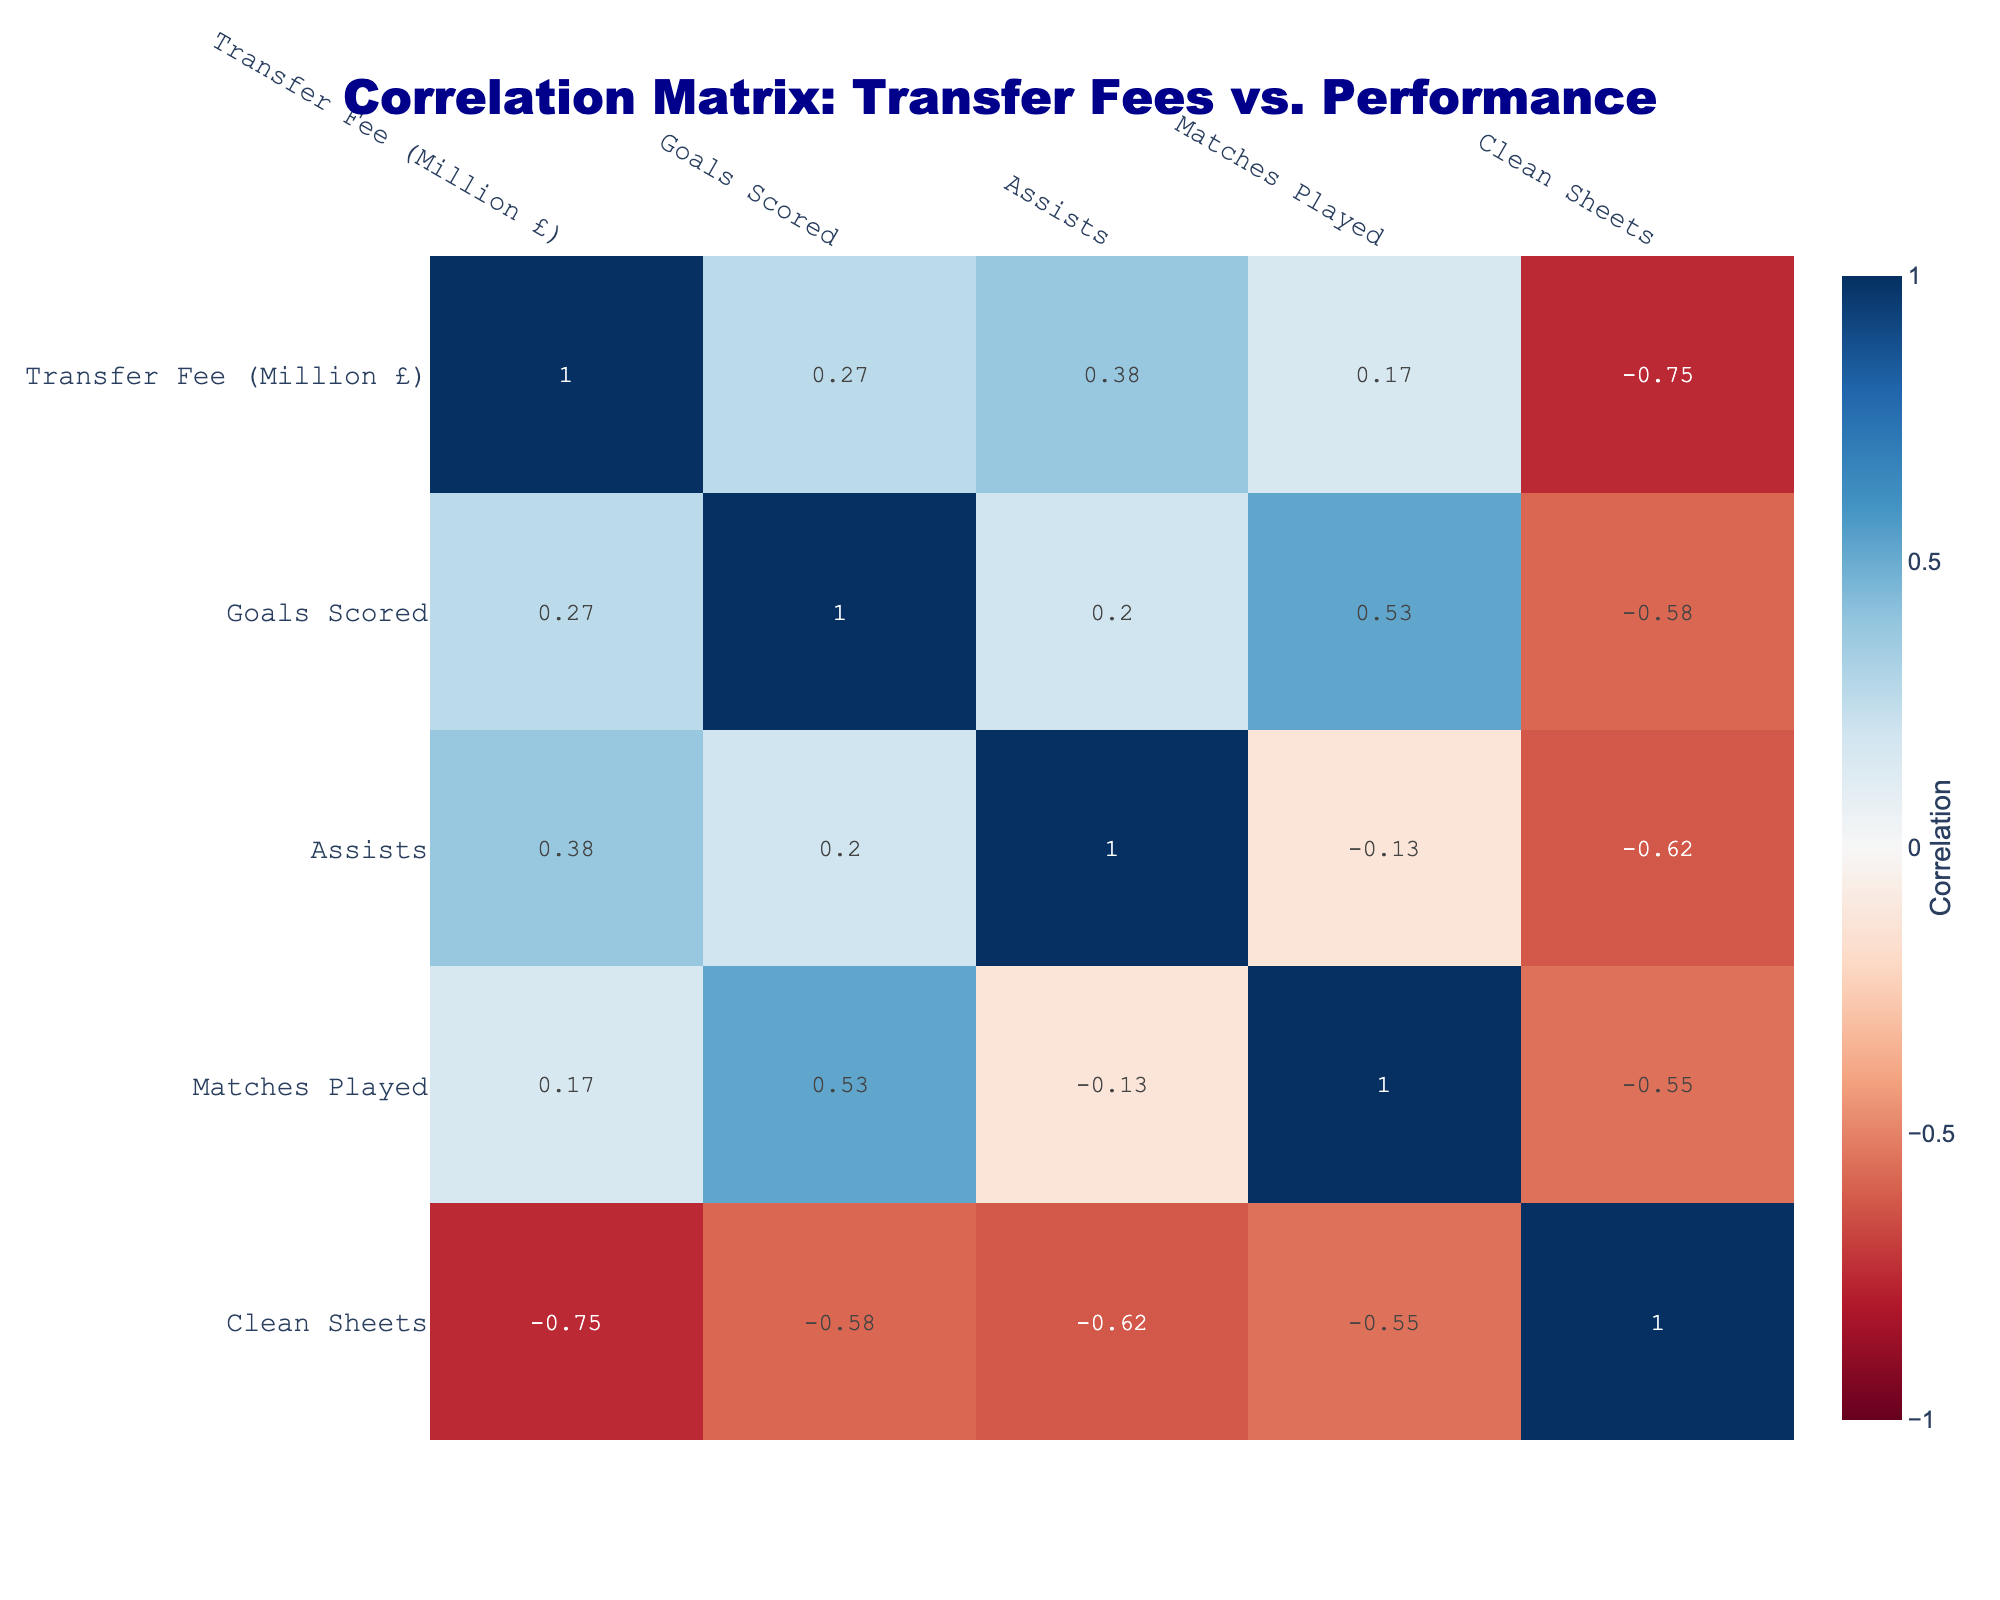What is the transfer fee of Jonson Clarke-Harris? By looking at the table, Jonson Clarke-Harris's row shows a transfer fee of 1.5 million pounds.
Answer: 1.5 million £ Which player has the highest number of goals scored? The table indicates that Jonson Clarke-Harris has scored 20 goals, which is higher than any other player listed.
Answer: Jonson Clarke-Harris What is the average number of assists across all players? To find the average, sum all assists (2 + 5 + 3 + 1 + 1 + 4 + 6 + 5 = 27) and then divide by the number of players (8). The average is 27/8 = 3.375.
Answer: 3.375 Is it true that Keenan Carole has more clean sheets than Jack Taylor? Keenan Carole has 1 clean sheet while Jack Taylor has 2 clean sheets, so the statement is false.
Answer: No What is the total number of matches played by all players? Adding the matches played by each player (30 + 28 + 31 + 29 + 25 + 30 + 27 + 26 = 256) gives the total number of matches played.
Answer: 256 Which player has the second highest transfer fee? By examining the transfer fees, Siriki Dembélé has a fee of 2.0 million pounds, and the next highest after that is Keenan Carole at 1.8 million pounds.
Answer: Keenan Carole Does Joe Ward have more goals than Harrison Burrows? Joe Ward has 7 goals, while Harrison Burrows has 6 goals. Therefore, the statement is true.
Answer: Yes What is the correlation between transfer fee and goals scored? The correlation coefficient is a numerical value representing how closely related the two variables are, and we would look at the intersection of the relevant row and column in the correlation table. The exact value would need to be derived from the correlation table output.
Answer: [dependent on table value] Has any player scored more than 6 goals and had 3 or more clean sheets? Analyzing the data, Jonson Clarke-Harris (20 goals, 1 clean sheet) and Siriki Dembélé (8 goals, 1 clean sheet) are ruled out as they don't meet the clean sheets criteria. Joe Ward (7 goals, 2 clean sheets) and Keenan Carole (5 goals, 1 clean sheet) are also ruled out. Only Harrison Burrows with 6 goals and 3 clean sheets meets the clean sheet criteria.
Answer: No 